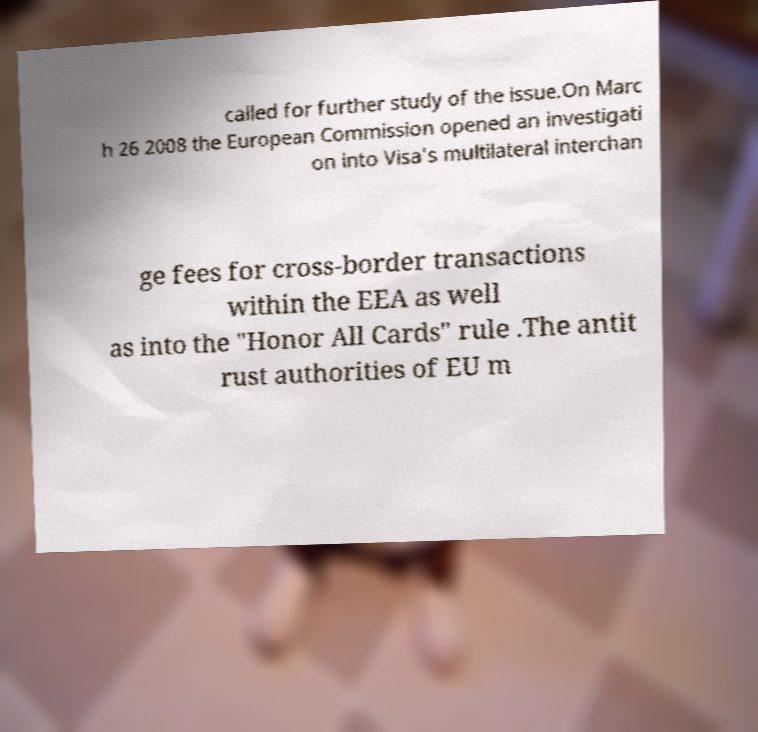What messages or text are displayed in this image? I need them in a readable, typed format. called for further study of the issue.On Marc h 26 2008 the European Commission opened an investigati on into Visa's multilateral interchan ge fees for cross-border transactions within the EEA as well as into the "Honor All Cards" rule .The antit rust authorities of EU m 